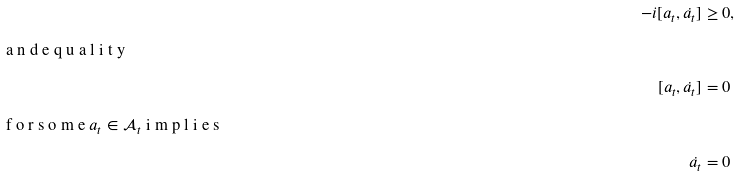Convert formula to latex. <formula><loc_0><loc_0><loc_500><loc_500>- i [ a _ { t } , \dot { a _ { t } } ] & \geq 0 , \\ \intertext { a n d e q u a l i t y } [ a _ { t } , \dot { a _ { t } } ] & = 0 \\ \intertext { f o r s o m e $ a _ { t } \in \mathcal { A } _ { t } $ i m p l i e s } \dot { a _ { t } } & = 0</formula> 